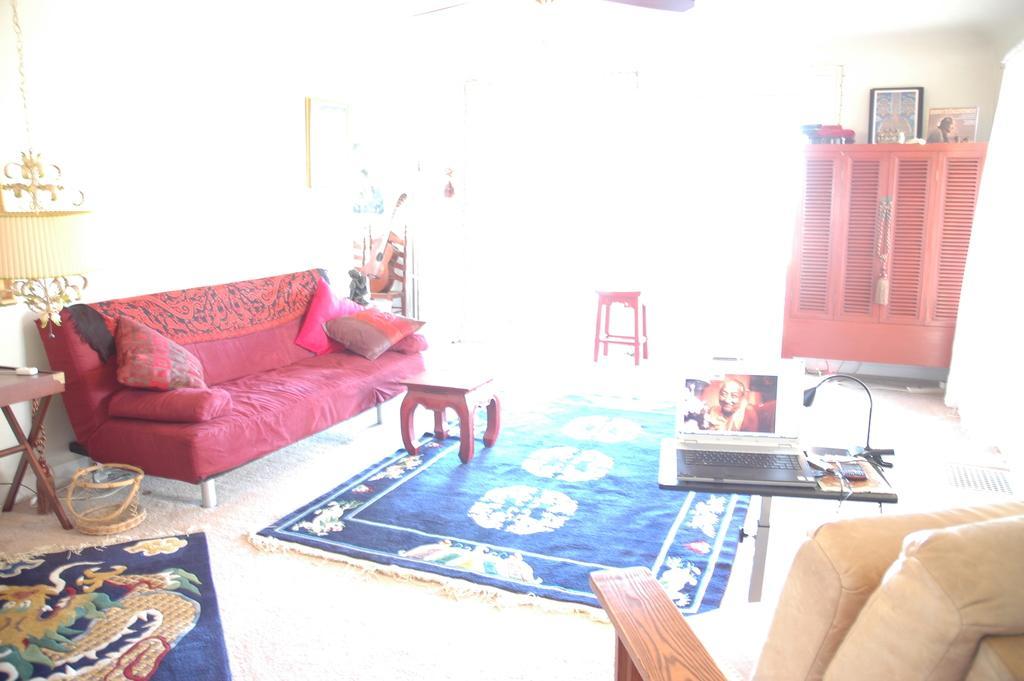How would you summarize this image in a sentence or two? The picture is clicked inside a house where there is a red sofa , two tables , chair and a red cup board. To the left side the image is saturated and has more brightness , we observe a fan attached to the ceiling. Blue color floor mats are placed on the floor. 